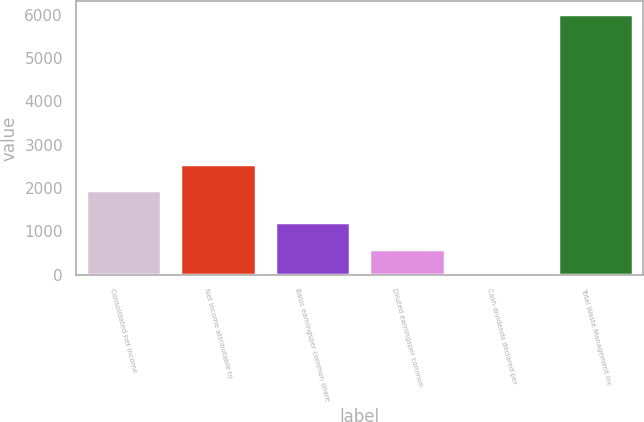Convert chart. <chart><loc_0><loc_0><loc_500><loc_500><bar_chart><fcel>Consolidated net income<fcel>Net income attributable to<fcel>Basic earningsper common share<fcel>Diluted earningsper common<fcel>Cash dividends declared per<fcel>Total Waste Management Inc<nl><fcel>1949<fcel>2550.73<fcel>1205.16<fcel>603.43<fcel>1.7<fcel>6019<nl></chart> 